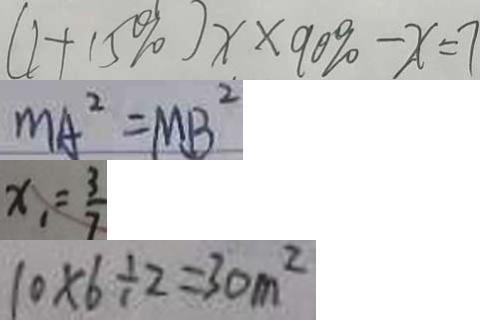Convert formula to latex. <formula><loc_0><loc_0><loc_500><loc_500>( 1 + 1 5 \% ) x \times 9 0 \% - x = 7 
 M A ^ { 2 } = M B ^ { 2 } 
 x _ { 1 } = \frac { 3 } { 7 } 
 1 0 \times 6 \div 2 = 3 0 m ^ { 2 }</formula> 